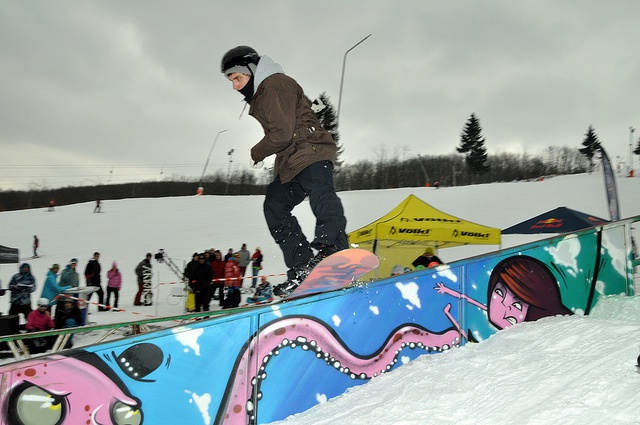Describe the objects in this image and their specific colors. I can see people in darkgray, black, and gray tones, people in darkgray, black, lightgray, and gray tones, snowboard in darkgray, salmon, and gray tones, people in darkgray, black, gray, maroon, and olive tones, and people in darkgray, black, gray, purple, and darkblue tones in this image. 